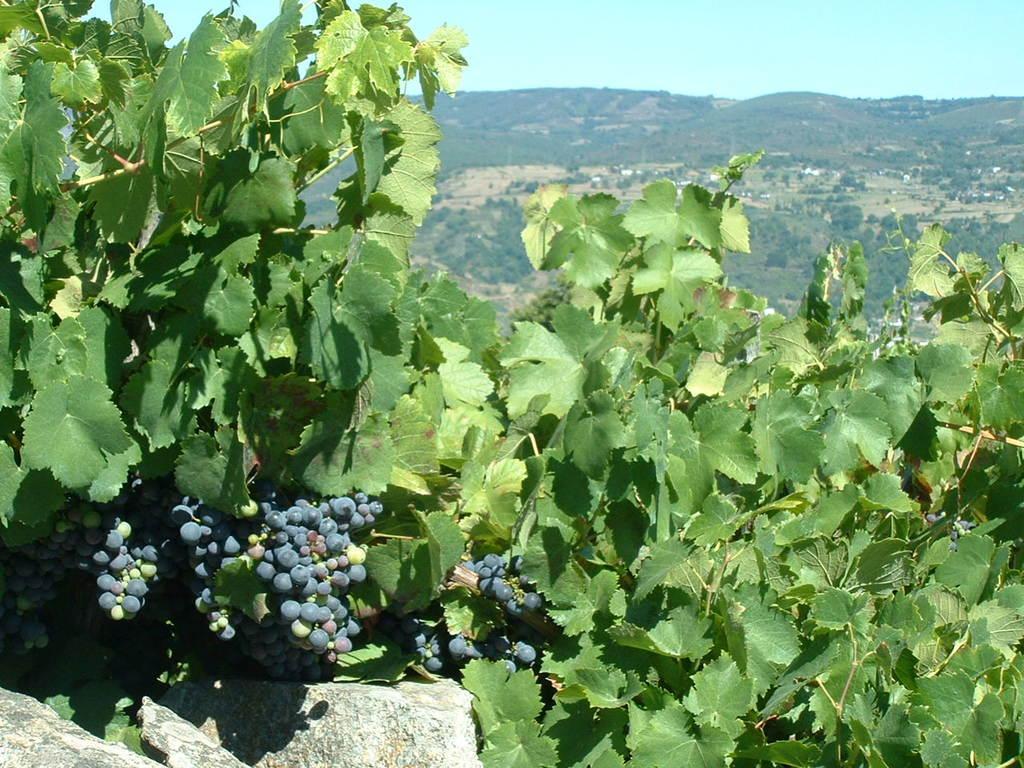Please provide a concise description of this image. In this image I can see number of green colour leaves and number of berries. In the background I can see number of trees and the sky. 